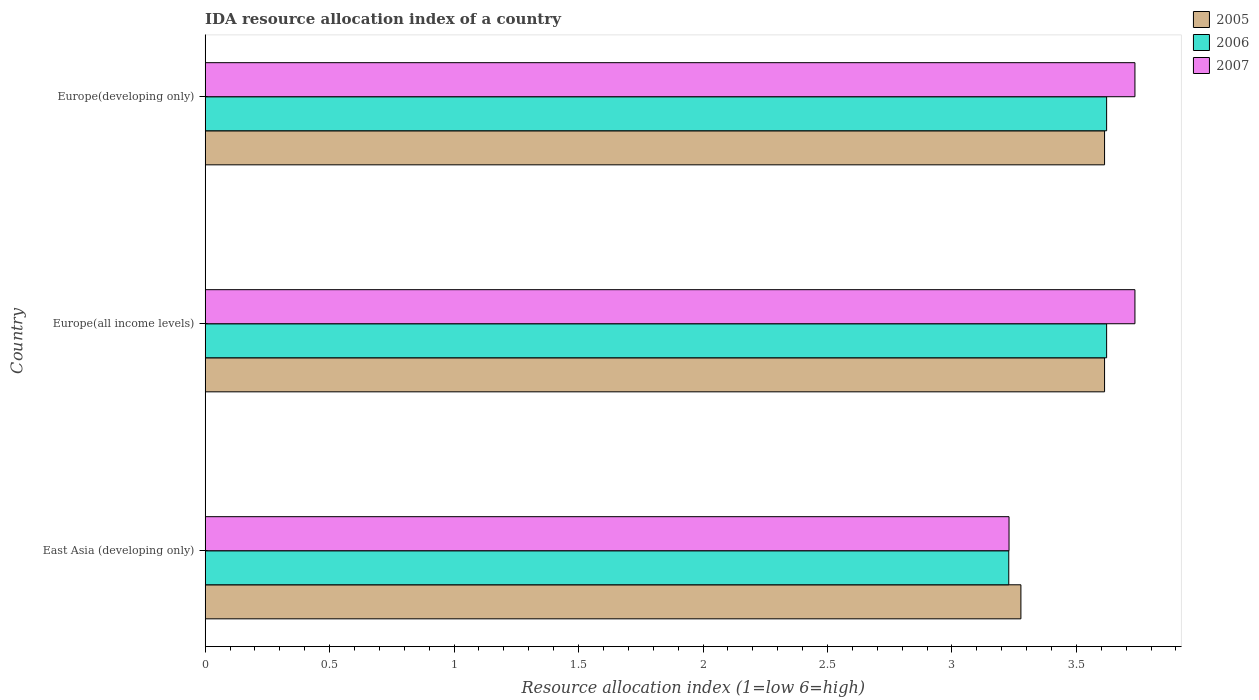How many different coloured bars are there?
Ensure brevity in your answer.  3. How many groups of bars are there?
Offer a very short reply. 3. How many bars are there on the 2nd tick from the top?
Offer a terse response. 3. How many bars are there on the 1st tick from the bottom?
Provide a short and direct response. 3. What is the label of the 2nd group of bars from the top?
Your answer should be compact. Europe(all income levels). What is the IDA resource allocation index in 2005 in Europe(all income levels)?
Offer a terse response. 3.61. Across all countries, what is the maximum IDA resource allocation index in 2007?
Keep it short and to the point. 3.74. Across all countries, what is the minimum IDA resource allocation index in 2005?
Your response must be concise. 3.28. In which country was the IDA resource allocation index in 2006 maximum?
Keep it short and to the point. Europe(all income levels). In which country was the IDA resource allocation index in 2006 minimum?
Ensure brevity in your answer.  East Asia (developing only). What is the total IDA resource allocation index in 2007 in the graph?
Your response must be concise. 10.7. What is the difference between the IDA resource allocation index in 2005 in Europe(all income levels) and the IDA resource allocation index in 2006 in Europe(developing only)?
Your answer should be compact. -0.01. What is the average IDA resource allocation index in 2005 per country?
Give a very brief answer. 3.5. What is the difference between the IDA resource allocation index in 2006 and IDA resource allocation index in 2005 in Europe(developing only)?
Offer a very short reply. 0.01. What is the ratio of the IDA resource allocation index in 2007 in East Asia (developing only) to that in Europe(developing only)?
Your answer should be very brief. 0.86. Is the difference between the IDA resource allocation index in 2006 in East Asia (developing only) and Europe(all income levels) greater than the difference between the IDA resource allocation index in 2005 in East Asia (developing only) and Europe(all income levels)?
Your answer should be compact. No. What is the difference between the highest and the second highest IDA resource allocation index in 2007?
Your response must be concise. 0. What is the difference between the highest and the lowest IDA resource allocation index in 2005?
Your answer should be very brief. 0.34. What does the 1st bar from the top in Europe(all income levels) represents?
Ensure brevity in your answer.  2007. Is it the case that in every country, the sum of the IDA resource allocation index in 2005 and IDA resource allocation index in 2006 is greater than the IDA resource allocation index in 2007?
Your response must be concise. Yes. How many bars are there?
Offer a terse response. 9. Are all the bars in the graph horizontal?
Your answer should be compact. Yes. Does the graph contain any zero values?
Your response must be concise. No. Does the graph contain grids?
Give a very brief answer. No. Where does the legend appear in the graph?
Provide a succinct answer. Top right. How many legend labels are there?
Your answer should be very brief. 3. What is the title of the graph?
Offer a terse response. IDA resource allocation index of a country. Does "1980" appear as one of the legend labels in the graph?
Your answer should be compact. No. What is the label or title of the X-axis?
Offer a very short reply. Resource allocation index (1=low 6=high). What is the Resource allocation index (1=low 6=high) of 2005 in East Asia (developing only)?
Give a very brief answer. 3.28. What is the Resource allocation index (1=low 6=high) in 2006 in East Asia (developing only)?
Your response must be concise. 3.23. What is the Resource allocation index (1=low 6=high) of 2007 in East Asia (developing only)?
Offer a terse response. 3.23. What is the Resource allocation index (1=low 6=high) of 2005 in Europe(all income levels)?
Offer a terse response. 3.61. What is the Resource allocation index (1=low 6=high) in 2006 in Europe(all income levels)?
Your response must be concise. 3.62. What is the Resource allocation index (1=low 6=high) of 2007 in Europe(all income levels)?
Give a very brief answer. 3.74. What is the Resource allocation index (1=low 6=high) of 2005 in Europe(developing only)?
Offer a terse response. 3.61. What is the Resource allocation index (1=low 6=high) in 2006 in Europe(developing only)?
Offer a terse response. 3.62. What is the Resource allocation index (1=low 6=high) in 2007 in Europe(developing only)?
Give a very brief answer. 3.74. Across all countries, what is the maximum Resource allocation index (1=low 6=high) in 2005?
Provide a short and direct response. 3.61. Across all countries, what is the maximum Resource allocation index (1=low 6=high) of 2006?
Offer a very short reply. 3.62. Across all countries, what is the maximum Resource allocation index (1=low 6=high) in 2007?
Offer a terse response. 3.74. Across all countries, what is the minimum Resource allocation index (1=low 6=high) in 2005?
Make the answer very short. 3.28. Across all countries, what is the minimum Resource allocation index (1=low 6=high) of 2006?
Offer a very short reply. 3.23. Across all countries, what is the minimum Resource allocation index (1=low 6=high) in 2007?
Make the answer very short. 3.23. What is the total Resource allocation index (1=low 6=high) of 2005 in the graph?
Provide a succinct answer. 10.5. What is the total Resource allocation index (1=low 6=high) of 2006 in the graph?
Offer a very short reply. 10.47. What is the total Resource allocation index (1=low 6=high) of 2007 in the graph?
Your answer should be compact. 10.7. What is the difference between the Resource allocation index (1=low 6=high) in 2005 in East Asia (developing only) and that in Europe(all income levels)?
Ensure brevity in your answer.  -0.34. What is the difference between the Resource allocation index (1=low 6=high) of 2006 in East Asia (developing only) and that in Europe(all income levels)?
Offer a terse response. -0.39. What is the difference between the Resource allocation index (1=low 6=high) of 2007 in East Asia (developing only) and that in Europe(all income levels)?
Keep it short and to the point. -0.51. What is the difference between the Resource allocation index (1=low 6=high) of 2005 in East Asia (developing only) and that in Europe(developing only)?
Offer a very short reply. -0.34. What is the difference between the Resource allocation index (1=low 6=high) of 2006 in East Asia (developing only) and that in Europe(developing only)?
Offer a very short reply. -0.39. What is the difference between the Resource allocation index (1=low 6=high) of 2007 in East Asia (developing only) and that in Europe(developing only)?
Keep it short and to the point. -0.51. What is the difference between the Resource allocation index (1=low 6=high) of 2005 in Europe(all income levels) and that in Europe(developing only)?
Offer a terse response. 0. What is the difference between the Resource allocation index (1=low 6=high) of 2005 in East Asia (developing only) and the Resource allocation index (1=low 6=high) of 2006 in Europe(all income levels)?
Your response must be concise. -0.34. What is the difference between the Resource allocation index (1=low 6=high) in 2005 in East Asia (developing only) and the Resource allocation index (1=low 6=high) in 2007 in Europe(all income levels)?
Keep it short and to the point. -0.46. What is the difference between the Resource allocation index (1=low 6=high) of 2006 in East Asia (developing only) and the Resource allocation index (1=low 6=high) of 2007 in Europe(all income levels)?
Keep it short and to the point. -0.51. What is the difference between the Resource allocation index (1=low 6=high) in 2005 in East Asia (developing only) and the Resource allocation index (1=low 6=high) in 2006 in Europe(developing only)?
Give a very brief answer. -0.34. What is the difference between the Resource allocation index (1=low 6=high) in 2005 in East Asia (developing only) and the Resource allocation index (1=low 6=high) in 2007 in Europe(developing only)?
Your response must be concise. -0.46. What is the difference between the Resource allocation index (1=low 6=high) in 2006 in East Asia (developing only) and the Resource allocation index (1=low 6=high) in 2007 in Europe(developing only)?
Offer a terse response. -0.51. What is the difference between the Resource allocation index (1=low 6=high) in 2005 in Europe(all income levels) and the Resource allocation index (1=low 6=high) in 2006 in Europe(developing only)?
Your answer should be very brief. -0.01. What is the difference between the Resource allocation index (1=low 6=high) of 2005 in Europe(all income levels) and the Resource allocation index (1=low 6=high) of 2007 in Europe(developing only)?
Your answer should be compact. -0.12. What is the difference between the Resource allocation index (1=low 6=high) in 2006 in Europe(all income levels) and the Resource allocation index (1=low 6=high) in 2007 in Europe(developing only)?
Provide a succinct answer. -0.11. What is the average Resource allocation index (1=low 6=high) in 2005 per country?
Offer a very short reply. 3.5. What is the average Resource allocation index (1=low 6=high) of 2006 per country?
Provide a short and direct response. 3.49. What is the average Resource allocation index (1=low 6=high) in 2007 per country?
Give a very brief answer. 3.57. What is the difference between the Resource allocation index (1=low 6=high) in 2005 and Resource allocation index (1=low 6=high) in 2006 in East Asia (developing only)?
Your answer should be compact. 0.05. What is the difference between the Resource allocation index (1=low 6=high) in 2005 and Resource allocation index (1=low 6=high) in 2007 in East Asia (developing only)?
Offer a terse response. 0.05. What is the difference between the Resource allocation index (1=low 6=high) in 2006 and Resource allocation index (1=low 6=high) in 2007 in East Asia (developing only)?
Give a very brief answer. -0. What is the difference between the Resource allocation index (1=low 6=high) of 2005 and Resource allocation index (1=low 6=high) of 2006 in Europe(all income levels)?
Provide a short and direct response. -0.01. What is the difference between the Resource allocation index (1=low 6=high) in 2005 and Resource allocation index (1=low 6=high) in 2007 in Europe(all income levels)?
Offer a very short reply. -0.12. What is the difference between the Resource allocation index (1=low 6=high) in 2006 and Resource allocation index (1=low 6=high) in 2007 in Europe(all income levels)?
Keep it short and to the point. -0.11. What is the difference between the Resource allocation index (1=low 6=high) of 2005 and Resource allocation index (1=low 6=high) of 2006 in Europe(developing only)?
Give a very brief answer. -0.01. What is the difference between the Resource allocation index (1=low 6=high) in 2005 and Resource allocation index (1=low 6=high) in 2007 in Europe(developing only)?
Ensure brevity in your answer.  -0.12. What is the difference between the Resource allocation index (1=low 6=high) in 2006 and Resource allocation index (1=low 6=high) in 2007 in Europe(developing only)?
Your response must be concise. -0.11. What is the ratio of the Resource allocation index (1=low 6=high) in 2005 in East Asia (developing only) to that in Europe(all income levels)?
Give a very brief answer. 0.91. What is the ratio of the Resource allocation index (1=low 6=high) of 2006 in East Asia (developing only) to that in Europe(all income levels)?
Make the answer very short. 0.89. What is the ratio of the Resource allocation index (1=low 6=high) of 2007 in East Asia (developing only) to that in Europe(all income levels)?
Your response must be concise. 0.86. What is the ratio of the Resource allocation index (1=low 6=high) of 2005 in East Asia (developing only) to that in Europe(developing only)?
Ensure brevity in your answer.  0.91. What is the ratio of the Resource allocation index (1=low 6=high) of 2006 in East Asia (developing only) to that in Europe(developing only)?
Your response must be concise. 0.89. What is the ratio of the Resource allocation index (1=low 6=high) of 2007 in East Asia (developing only) to that in Europe(developing only)?
Your answer should be compact. 0.86. What is the ratio of the Resource allocation index (1=low 6=high) of 2007 in Europe(all income levels) to that in Europe(developing only)?
Provide a succinct answer. 1. What is the difference between the highest and the second highest Resource allocation index (1=low 6=high) of 2005?
Keep it short and to the point. 0. What is the difference between the highest and the second highest Resource allocation index (1=low 6=high) of 2007?
Your answer should be compact. 0. What is the difference between the highest and the lowest Resource allocation index (1=low 6=high) in 2005?
Provide a succinct answer. 0.34. What is the difference between the highest and the lowest Resource allocation index (1=low 6=high) in 2006?
Your response must be concise. 0.39. What is the difference between the highest and the lowest Resource allocation index (1=low 6=high) of 2007?
Offer a terse response. 0.51. 